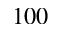<formula> <loc_0><loc_0><loc_500><loc_500>1 0 0</formula> 